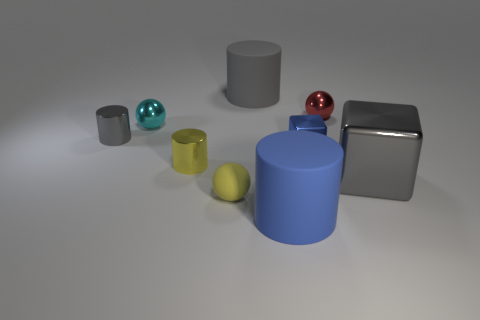Add 1 blue things. How many objects exist? 10 Subtract all small metallic spheres. How many spheres are left? 1 Subtract 1 cylinders. How many cylinders are left? 3 Subtract all yellow spheres. How many spheres are left? 2 Subtract 0 brown cylinders. How many objects are left? 9 Subtract all cubes. How many objects are left? 7 Subtract all blue cylinders. Subtract all blue balls. How many cylinders are left? 3 Subtract all gray cylinders. How many gray cubes are left? 1 Subtract all small yellow cylinders. Subtract all tiny cyan balls. How many objects are left? 7 Add 6 rubber spheres. How many rubber spheres are left? 7 